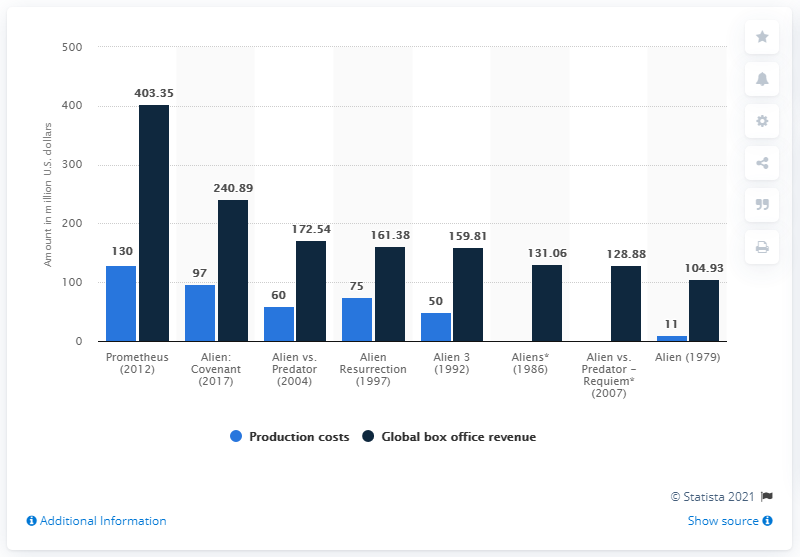Mention a couple of crucial points in this snapshot. The value of the highest bar is 403.35. The production costs and global box office revenue for Prometheus were 273.35 and ..... respectively. 